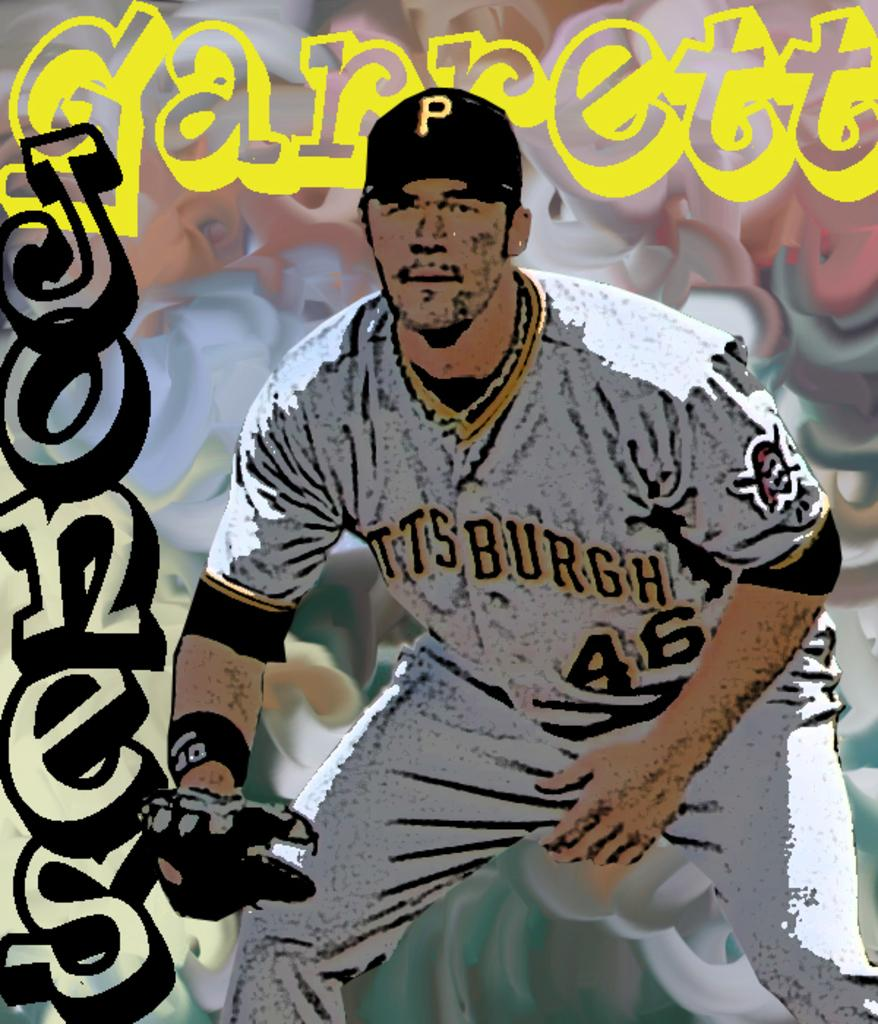<image>
Share a concise interpretation of the image provided. Garrett Jones wearing a Pittsburgh jersey squats and looks forward. 